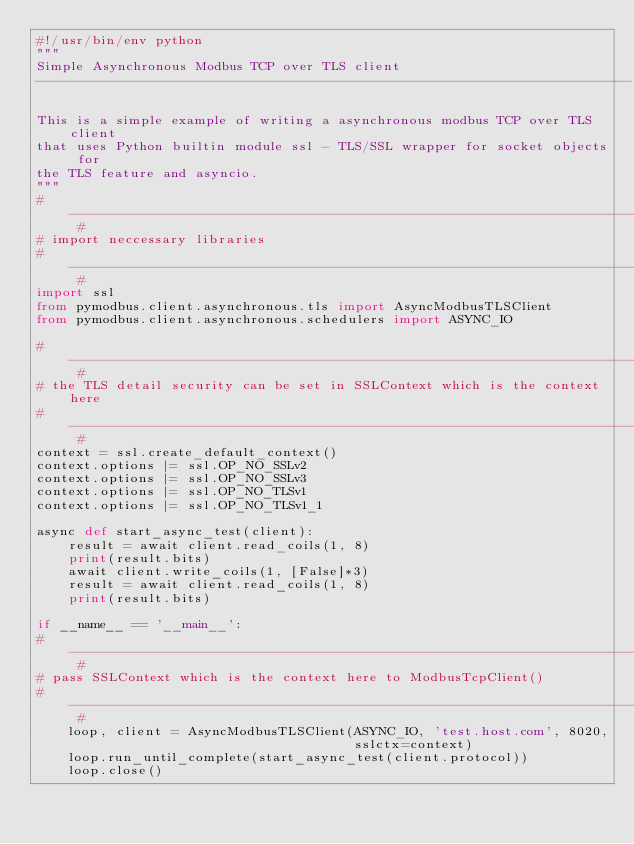<code> <loc_0><loc_0><loc_500><loc_500><_Python_>#!/usr/bin/env python
"""
Simple Asynchronous Modbus TCP over TLS client
---------------------------------------------------------------------------

This is a simple example of writing a asynchronous modbus TCP over TLS client
that uses Python builtin module ssl - TLS/SSL wrapper for socket objects for
the TLS feature and asyncio.
"""
# -------------------------------------------------------------------------- #
# import neccessary libraries
# -------------------------------------------------------------------------- #
import ssl
from pymodbus.client.asynchronous.tls import AsyncModbusTLSClient
from pymodbus.client.asynchronous.schedulers import ASYNC_IO

# -------------------------------------------------------------------------- #
# the TLS detail security can be set in SSLContext which is the context here
# -------------------------------------------------------------------------- #
context = ssl.create_default_context()
context.options |= ssl.OP_NO_SSLv2
context.options |= ssl.OP_NO_SSLv3
context.options |= ssl.OP_NO_TLSv1
context.options |= ssl.OP_NO_TLSv1_1

async def start_async_test(client):
    result = await client.read_coils(1, 8)
    print(result.bits)
    await client.write_coils(1, [False]*3)
    result = await client.read_coils(1, 8)
    print(result.bits)

if __name__ == '__main__':
# -------------------------------------------------------------------------- #
# pass SSLContext which is the context here to ModbusTcpClient()
# -------------------------------------------------------------------------- #
    loop, client = AsyncModbusTLSClient(ASYNC_IO, 'test.host.com', 8020,
                                        sslctx=context)
    loop.run_until_complete(start_async_test(client.protocol))
    loop.close()
</code> 